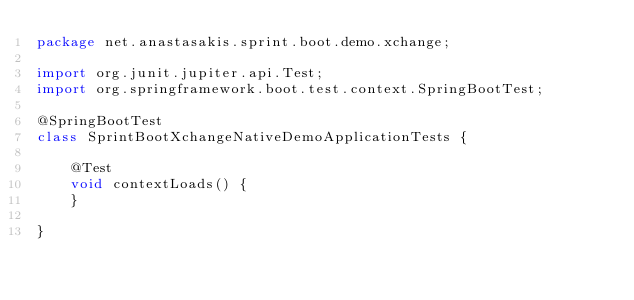Convert code to text. <code><loc_0><loc_0><loc_500><loc_500><_Java_>package net.anastasakis.sprint.boot.demo.xchange;

import org.junit.jupiter.api.Test;
import org.springframework.boot.test.context.SpringBootTest;

@SpringBootTest
class SprintBootXchangeNativeDemoApplicationTests {

    @Test
    void contextLoads() {
    }

}
</code> 